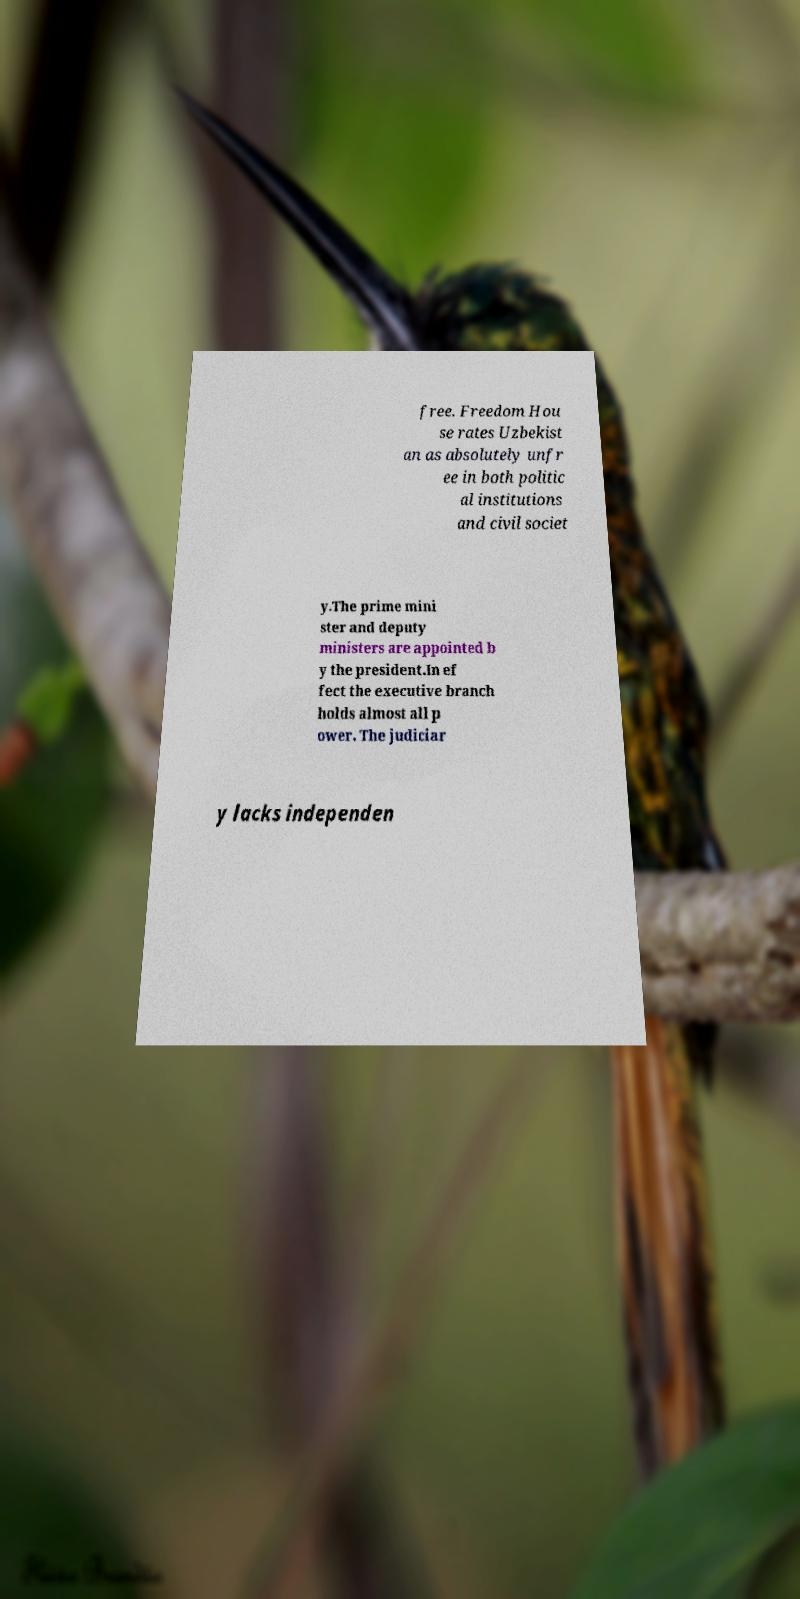Please identify and transcribe the text found in this image. free. Freedom Hou se rates Uzbekist an as absolutely unfr ee in both politic al institutions and civil societ y.The prime mini ster and deputy ministers are appointed b y the president.In ef fect the executive branch holds almost all p ower. The judiciar y lacks independen 